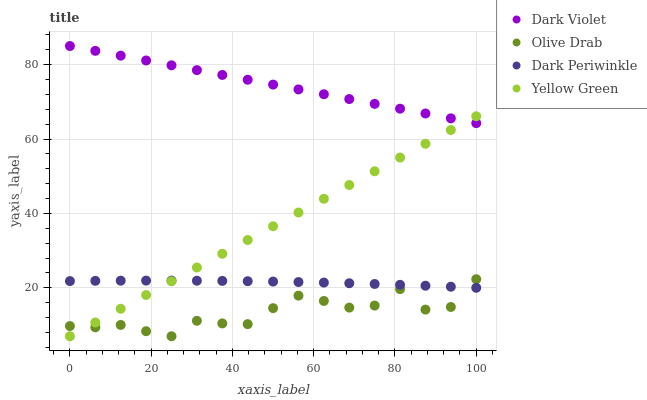Does Olive Drab have the minimum area under the curve?
Answer yes or no. Yes. Does Dark Violet have the maximum area under the curve?
Answer yes or no. Yes. Does Dark Violet have the minimum area under the curve?
Answer yes or no. No. Does Olive Drab have the maximum area under the curve?
Answer yes or no. No. Is Yellow Green the smoothest?
Answer yes or no. Yes. Is Olive Drab the roughest?
Answer yes or no. Yes. Is Dark Violet the smoothest?
Answer yes or no. No. Is Dark Violet the roughest?
Answer yes or no. No. Does Yellow Green have the lowest value?
Answer yes or no. Yes. Does Dark Violet have the lowest value?
Answer yes or no. No. Does Dark Violet have the highest value?
Answer yes or no. Yes. Does Olive Drab have the highest value?
Answer yes or no. No. Is Olive Drab less than Dark Violet?
Answer yes or no. Yes. Is Dark Violet greater than Dark Periwinkle?
Answer yes or no. Yes. Does Olive Drab intersect Yellow Green?
Answer yes or no. Yes. Is Olive Drab less than Yellow Green?
Answer yes or no. No. Is Olive Drab greater than Yellow Green?
Answer yes or no. No. Does Olive Drab intersect Dark Violet?
Answer yes or no. No. 